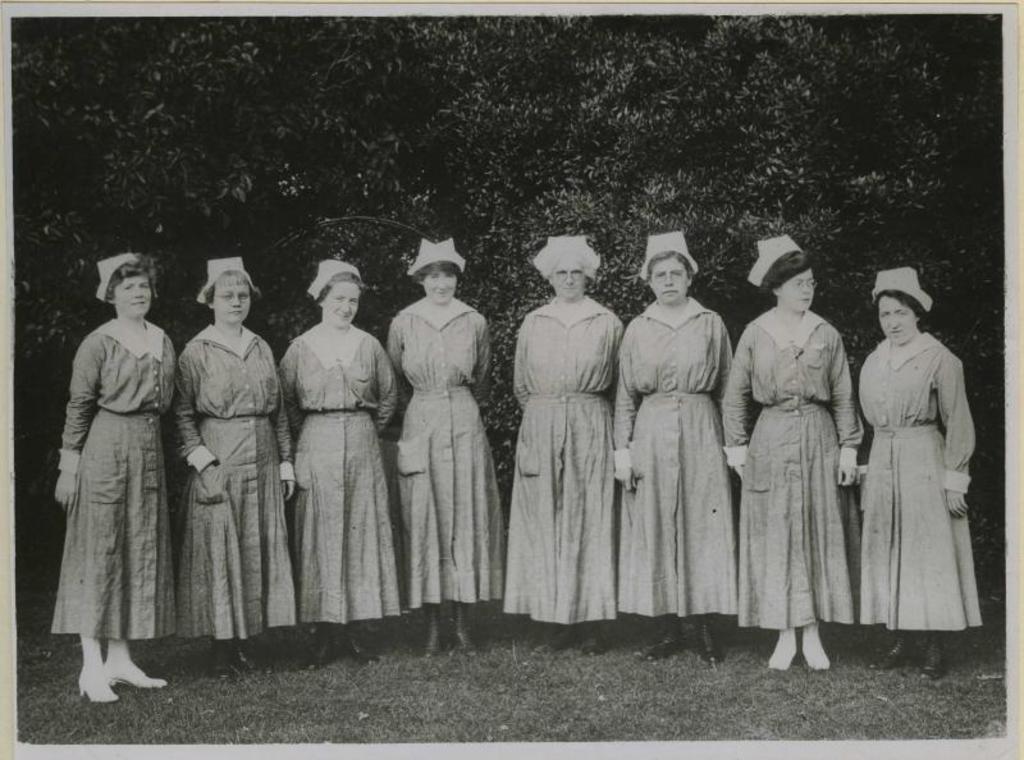Could you give a brief overview of what you see in this image? In this image I can see there are few persons standing on grass , background I can see trees and the person is smiling all are woman 